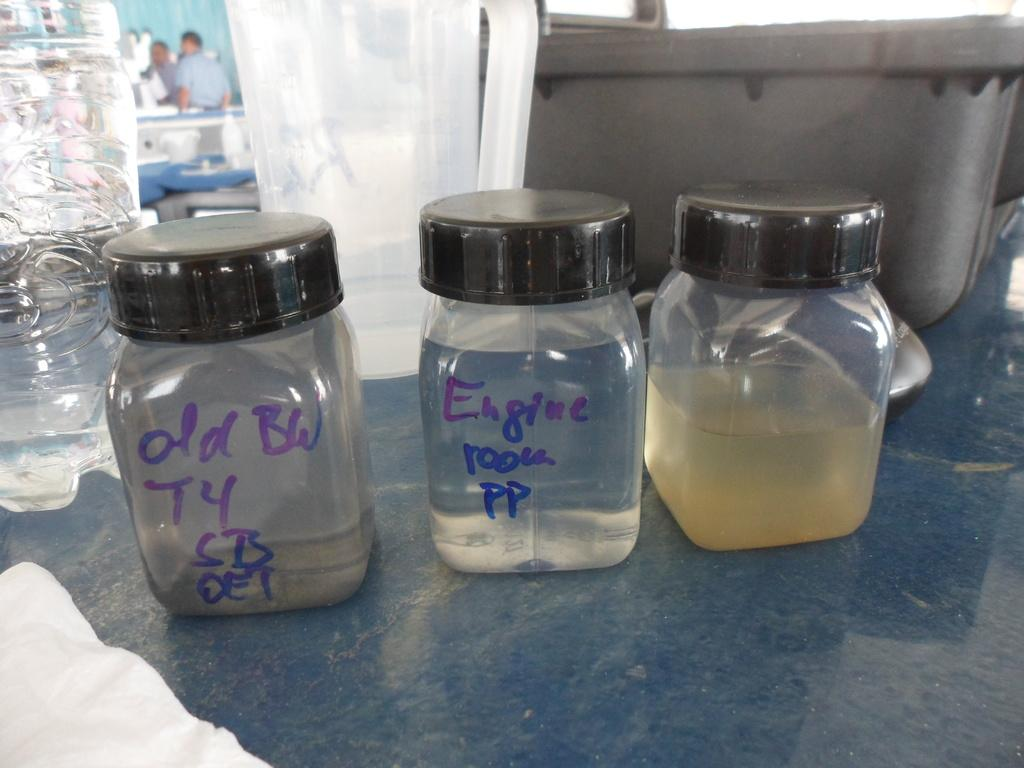<image>
Create a compact narrative representing the image presented. Three clear bottles with labels that says "old BW" or "Engine room". 